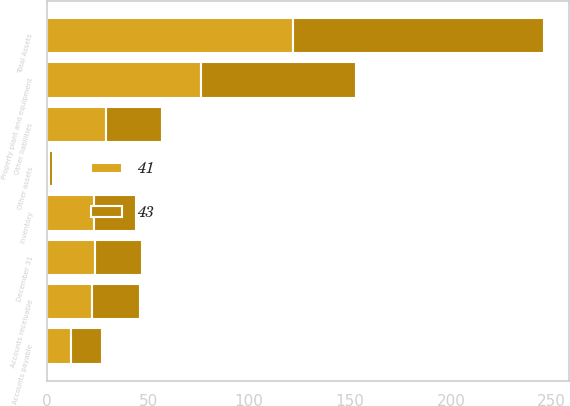Convert chart. <chart><loc_0><loc_0><loc_500><loc_500><stacked_bar_chart><ecel><fcel>December 31<fcel>Accounts receivable<fcel>Inventory<fcel>Property plant and equipment<fcel>Other assets<fcel>Total Assets<fcel>Accounts payable<fcel>Other liabilities<nl><fcel>43<fcel>23.5<fcel>24<fcel>21<fcel>77<fcel>2<fcel>124<fcel>15<fcel>28<nl><fcel>41<fcel>23.5<fcel>22<fcel>23<fcel>76<fcel>1<fcel>122<fcel>12<fcel>29<nl></chart> 